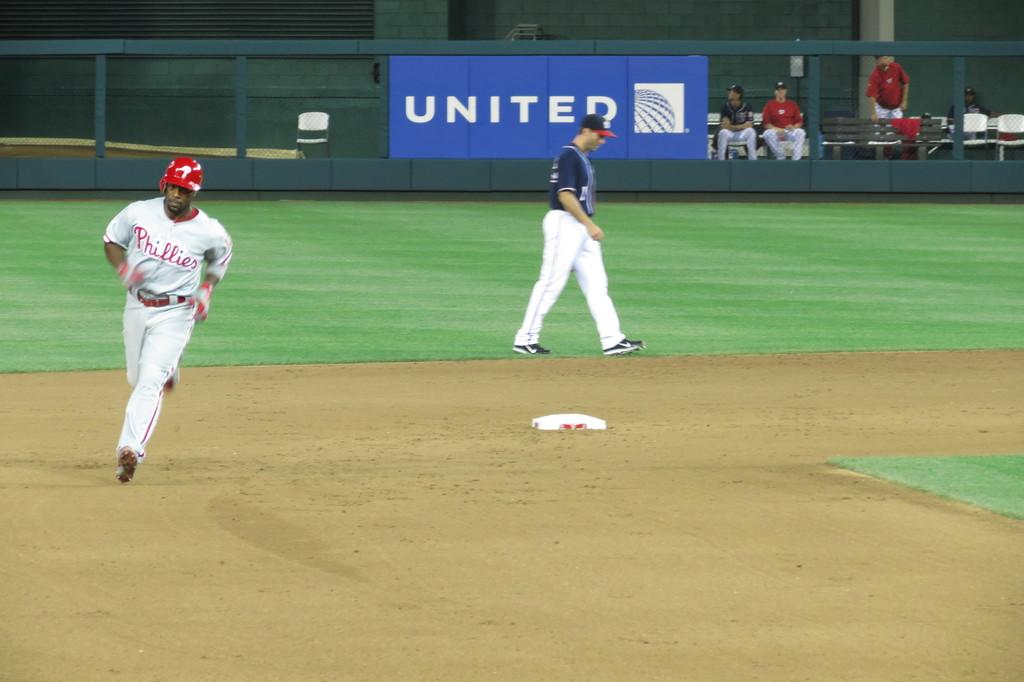Provide a one-sentence caption for the provided image. a baseball game with a player from the Philadelphia phillies running the bases. 